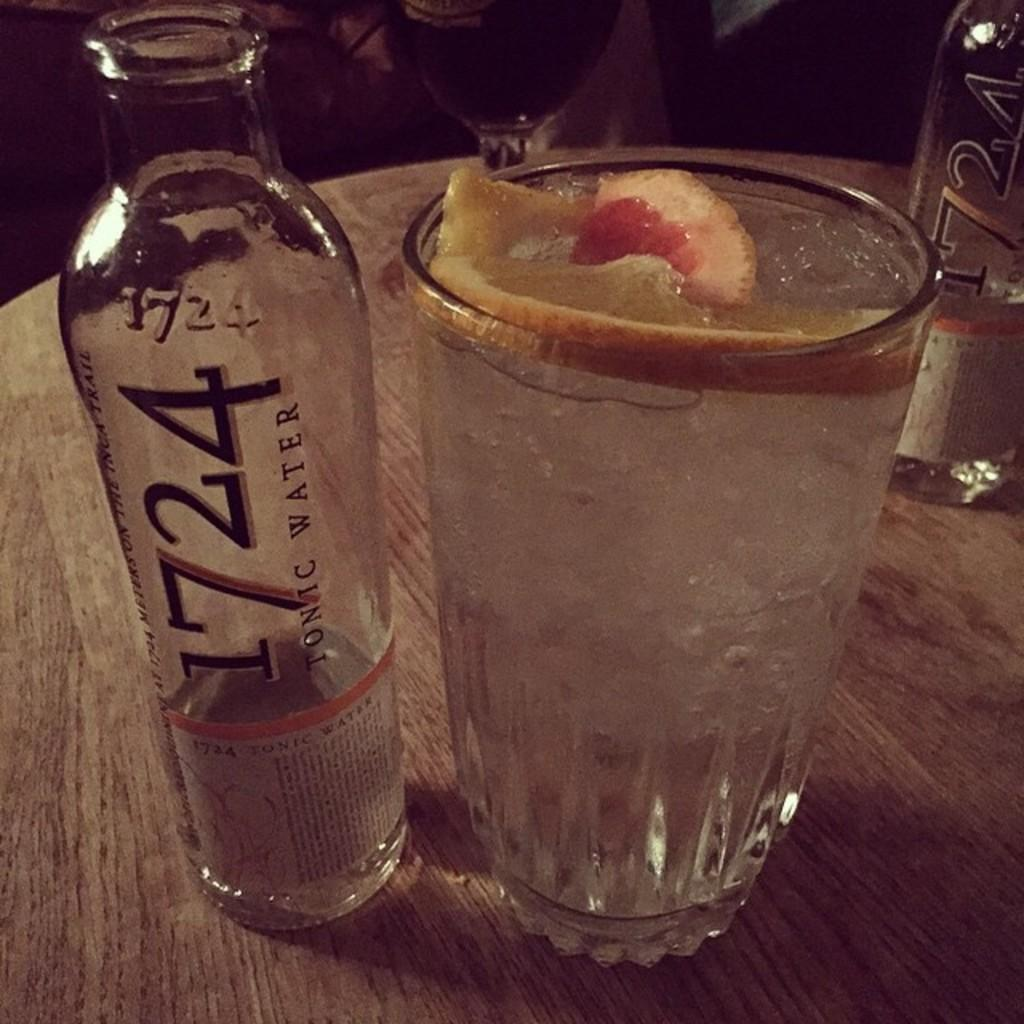How many bottles are visible in the image? There are 2 bottles in the image. What else can be seen in the image besides the bottles? There is a glass in the image. What is inside the glass? There is a fruit in the glass. What statement does the daughter make about the order of the bottles in the image? There is no daughter present in the image, and therefore no statement can be attributed to her. 